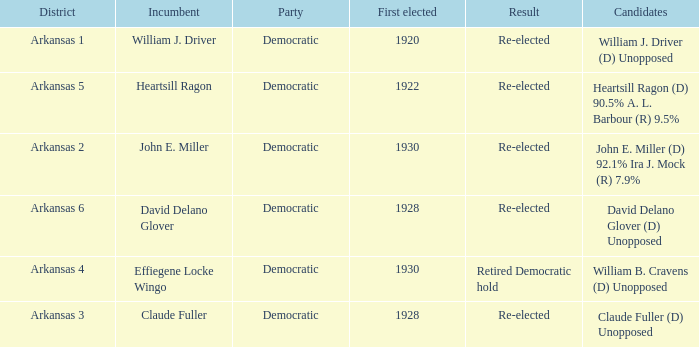Parse the table in full. {'header': ['District', 'Incumbent', 'Party', 'First elected', 'Result', 'Candidates'], 'rows': [['Arkansas 1', 'William J. Driver', 'Democratic', '1920', 'Re-elected', 'William J. Driver (D) Unopposed'], ['Arkansas 5', 'Heartsill Ragon', 'Democratic', '1922', 'Re-elected', 'Heartsill Ragon (D) 90.5% A. L. Barbour (R) 9.5%'], ['Arkansas 2', 'John E. Miller', 'Democratic', '1930', 'Re-elected', 'John E. Miller (D) 92.1% Ira J. Mock (R) 7.9%'], ['Arkansas 6', 'David Delano Glover', 'Democratic', '1928', 'Re-elected', 'David Delano Glover (D) Unopposed'], ['Arkansas 4', 'Effiegene Locke Wingo', 'Democratic', '1930', 'Retired Democratic hold', 'William B. Cravens (D) Unopposed'], ['Arkansas 3', 'Claude Fuller', 'Democratic', '1928', 'Re-elected', 'Claude Fuller (D) Unopposed']]} What year was incumbent Claude Fuller first elected?  1928.0. 